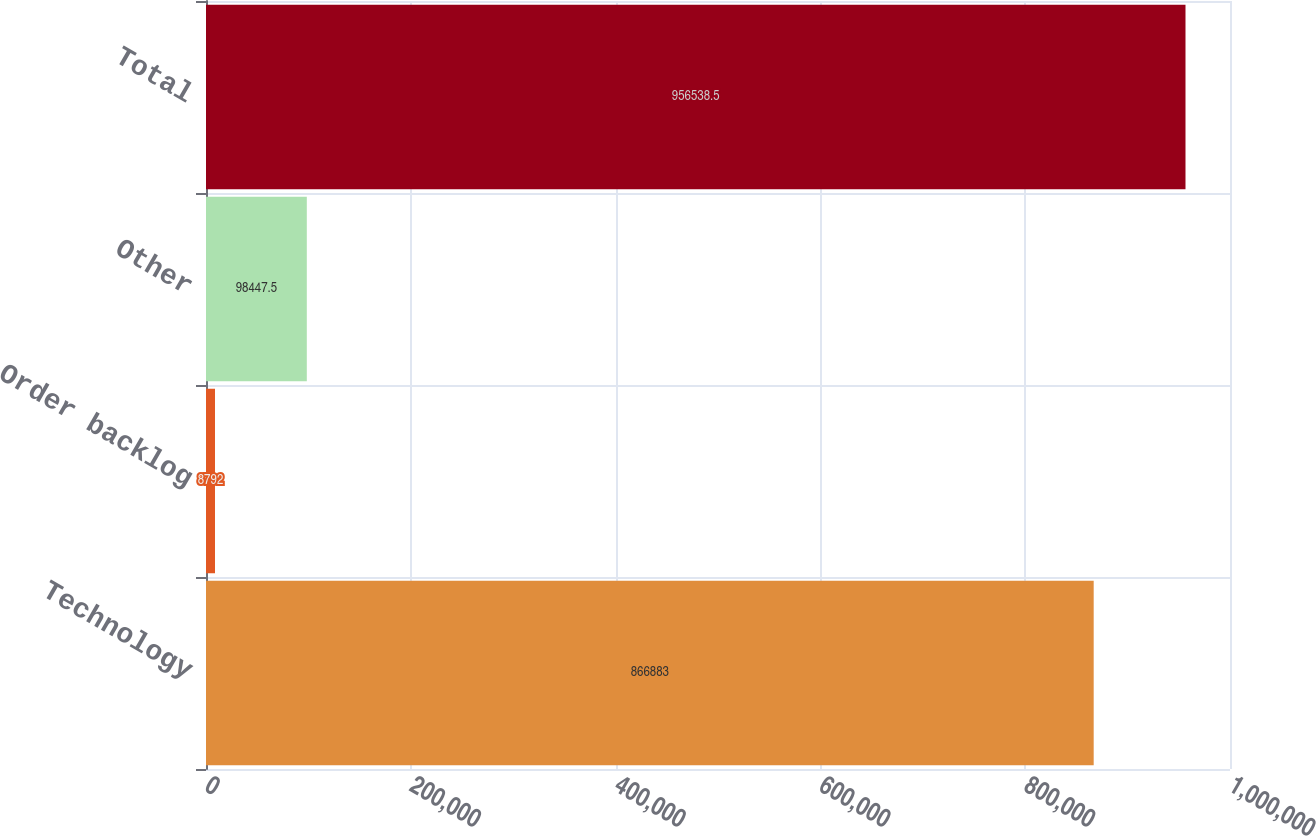Convert chart. <chart><loc_0><loc_0><loc_500><loc_500><bar_chart><fcel>Technology<fcel>Order backlog<fcel>Other<fcel>Total<nl><fcel>866883<fcel>8792<fcel>98447.5<fcel>956538<nl></chart> 